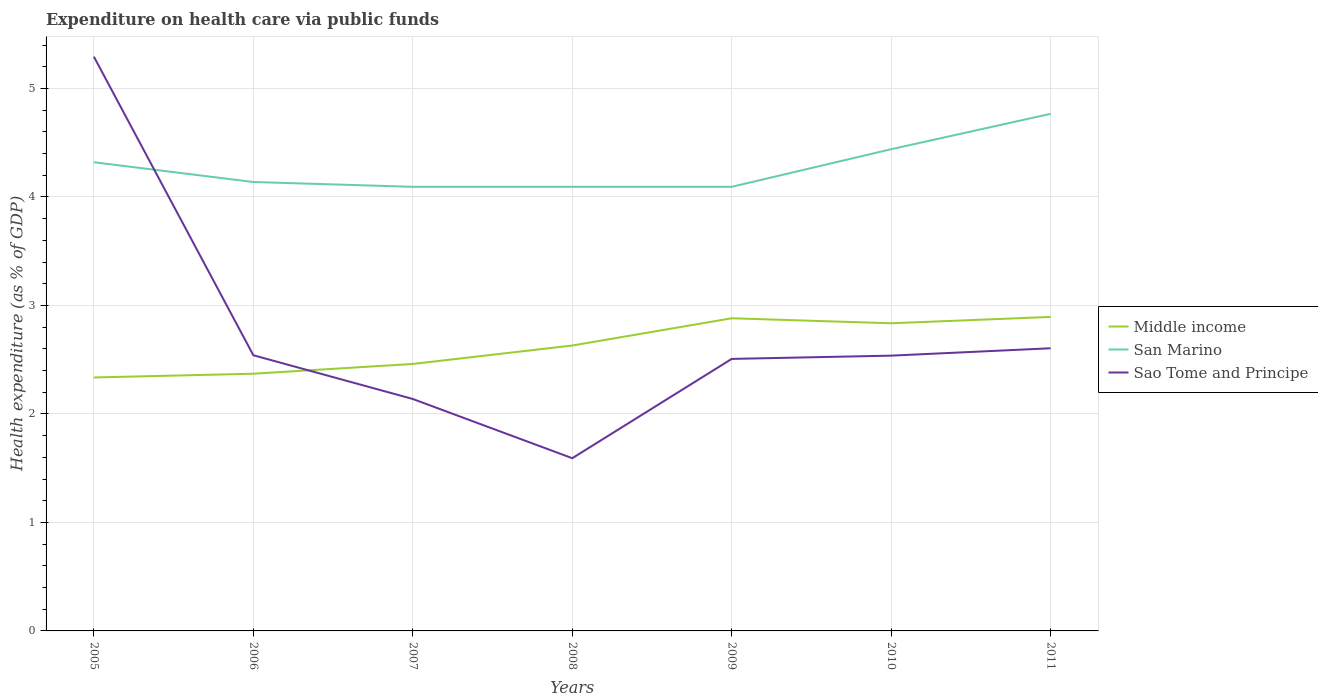Is the number of lines equal to the number of legend labels?
Keep it short and to the point. Yes. Across all years, what is the maximum expenditure made on health care in Middle income?
Ensure brevity in your answer.  2.34. In which year was the expenditure made on health care in San Marino maximum?
Offer a very short reply. 2009. What is the total expenditure made on health care in San Marino in the graph?
Offer a terse response. -0.67. What is the difference between the highest and the second highest expenditure made on health care in Middle income?
Your response must be concise. 0.56. What is the difference between the highest and the lowest expenditure made on health care in San Marino?
Provide a succinct answer. 3. Is the expenditure made on health care in Middle income strictly greater than the expenditure made on health care in San Marino over the years?
Give a very brief answer. Yes. How many lines are there?
Your response must be concise. 3. What is the difference between two consecutive major ticks on the Y-axis?
Offer a very short reply. 1. Does the graph contain any zero values?
Provide a short and direct response. No. Does the graph contain grids?
Keep it short and to the point. Yes. How many legend labels are there?
Ensure brevity in your answer.  3. What is the title of the graph?
Offer a very short reply. Expenditure on health care via public funds. What is the label or title of the Y-axis?
Provide a short and direct response. Health expenditure (as % of GDP). What is the Health expenditure (as % of GDP) in Middle income in 2005?
Ensure brevity in your answer.  2.34. What is the Health expenditure (as % of GDP) of San Marino in 2005?
Your answer should be compact. 4.32. What is the Health expenditure (as % of GDP) in Sao Tome and Principe in 2005?
Ensure brevity in your answer.  5.29. What is the Health expenditure (as % of GDP) in Middle income in 2006?
Offer a terse response. 2.37. What is the Health expenditure (as % of GDP) in San Marino in 2006?
Give a very brief answer. 4.14. What is the Health expenditure (as % of GDP) of Sao Tome and Principe in 2006?
Give a very brief answer. 2.54. What is the Health expenditure (as % of GDP) of Middle income in 2007?
Your response must be concise. 2.46. What is the Health expenditure (as % of GDP) in San Marino in 2007?
Keep it short and to the point. 4.09. What is the Health expenditure (as % of GDP) of Sao Tome and Principe in 2007?
Give a very brief answer. 2.14. What is the Health expenditure (as % of GDP) in Middle income in 2008?
Offer a very short reply. 2.63. What is the Health expenditure (as % of GDP) of San Marino in 2008?
Provide a short and direct response. 4.09. What is the Health expenditure (as % of GDP) of Sao Tome and Principe in 2008?
Your response must be concise. 1.59. What is the Health expenditure (as % of GDP) of Middle income in 2009?
Your answer should be very brief. 2.88. What is the Health expenditure (as % of GDP) of San Marino in 2009?
Your response must be concise. 4.09. What is the Health expenditure (as % of GDP) in Sao Tome and Principe in 2009?
Your answer should be compact. 2.51. What is the Health expenditure (as % of GDP) in Middle income in 2010?
Make the answer very short. 2.84. What is the Health expenditure (as % of GDP) of San Marino in 2010?
Give a very brief answer. 4.44. What is the Health expenditure (as % of GDP) in Sao Tome and Principe in 2010?
Your response must be concise. 2.54. What is the Health expenditure (as % of GDP) in Middle income in 2011?
Provide a succinct answer. 2.89. What is the Health expenditure (as % of GDP) in San Marino in 2011?
Provide a succinct answer. 4.77. What is the Health expenditure (as % of GDP) of Sao Tome and Principe in 2011?
Make the answer very short. 2.61. Across all years, what is the maximum Health expenditure (as % of GDP) in Middle income?
Your answer should be compact. 2.89. Across all years, what is the maximum Health expenditure (as % of GDP) in San Marino?
Ensure brevity in your answer.  4.77. Across all years, what is the maximum Health expenditure (as % of GDP) of Sao Tome and Principe?
Your answer should be very brief. 5.29. Across all years, what is the minimum Health expenditure (as % of GDP) of Middle income?
Provide a succinct answer. 2.34. Across all years, what is the minimum Health expenditure (as % of GDP) of San Marino?
Your answer should be very brief. 4.09. Across all years, what is the minimum Health expenditure (as % of GDP) in Sao Tome and Principe?
Your response must be concise. 1.59. What is the total Health expenditure (as % of GDP) of Middle income in the graph?
Offer a terse response. 18.41. What is the total Health expenditure (as % of GDP) in San Marino in the graph?
Offer a terse response. 29.95. What is the total Health expenditure (as % of GDP) in Sao Tome and Principe in the graph?
Your answer should be compact. 19.21. What is the difference between the Health expenditure (as % of GDP) in Middle income in 2005 and that in 2006?
Your response must be concise. -0.03. What is the difference between the Health expenditure (as % of GDP) in San Marino in 2005 and that in 2006?
Ensure brevity in your answer.  0.18. What is the difference between the Health expenditure (as % of GDP) in Sao Tome and Principe in 2005 and that in 2006?
Offer a terse response. 2.75. What is the difference between the Health expenditure (as % of GDP) in Middle income in 2005 and that in 2007?
Provide a short and direct response. -0.12. What is the difference between the Health expenditure (as % of GDP) in San Marino in 2005 and that in 2007?
Offer a very short reply. 0.23. What is the difference between the Health expenditure (as % of GDP) of Sao Tome and Principe in 2005 and that in 2007?
Make the answer very short. 3.16. What is the difference between the Health expenditure (as % of GDP) in Middle income in 2005 and that in 2008?
Provide a succinct answer. -0.29. What is the difference between the Health expenditure (as % of GDP) in San Marino in 2005 and that in 2008?
Make the answer very short. 0.23. What is the difference between the Health expenditure (as % of GDP) in Sao Tome and Principe in 2005 and that in 2008?
Your answer should be very brief. 3.7. What is the difference between the Health expenditure (as % of GDP) in Middle income in 2005 and that in 2009?
Your answer should be compact. -0.55. What is the difference between the Health expenditure (as % of GDP) of San Marino in 2005 and that in 2009?
Make the answer very short. 0.23. What is the difference between the Health expenditure (as % of GDP) in Sao Tome and Principe in 2005 and that in 2009?
Your answer should be very brief. 2.79. What is the difference between the Health expenditure (as % of GDP) of Middle income in 2005 and that in 2010?
Your answer should be compact. -0.5. What is the difference between the Health expenditure (as % of GDP) in San Marino in 2005 and that in 2010?
Keep it short and to the point. -0.12. What is the difference between the Health expenditure (as % of GDP) in Sao Tome and Principe in 2005 and that in 2010?
Provide a short and direct response. 2.76. What is the difference between the Health expenditure (as % of GDP) in Middle income in 2005 and that in 2011?
Provide a short and direct response. -0.56. What is the difference between the Health expenditure (as % of GDP) in San Marino in 2005 and that in 2011?
Keep it short and to the point. -0.45. What is the difference between the Health expenditure (as % of GDP) in Sao Tome and Principe in 2005 and that in 2011?
Keep it short and to the point. 2.69. What is the difference between the Health expenditure (as % of GDP) in Middle income in 2006 and that in 2007?
Ensure brevity in your answer.  -0.09. What is the difference between the Health expenditure (as % of GDP) in San Marino in 2006 and that in 2007?
Provide a short and direct response. 0.04. What is the difference between the Health expenditure (as % of GDP) in Sao Tome and Principe in 2006 and that in 2007?
Make the answer very short. 0.4. What is the difference between the Health expenditure (as % of GDP) of Middle income in 2006 and that in 2008?
Keep it short and to the point. -0.26. What is the difference between the Health expenditure (as % of GDP) of San Marino in 2006 and that in 2008?
Offer a very short reply. 0.04. What is the difference between the Health expenditure (as % of GDP) in Sao Tome and Principe in 2006 and that in 2008?
Ensure brevity in your answer.  0.95. What is the difference between the Health expenditure (as % of GDP) of Middle income in 2006 and that in 2009?
Make the answer very short. -0.51. What is the difference between the Health expenditure (as % of GDP) in San Marino in 2006 and that in 2009?
Your answer should be very brief. 0.04. What is the difference between the Health expenditure (as % of GDP) of Sao Tome and Principe in 2006 and that in 2009?
Your response must be concise. 0.03. What is the difference between the Health expenditure (as % of GDP) in Middle income in 2006 and that in 2010?
Keep it short and to the point. -0.47. What is the difference between the Health expenditure (as % of GDP) of San Marino in 2006 and that in 2010?
Give a very brief answer. -0.3. What is the difference between the Health expenditure (as % of GDP) in Sao Tome and Principe in 2006 and that in 2010?
Make the answer very short. 0. What is the difference between the Health expenditure (as % of GDP) in Middle income in 2006 and that in 2011?
Your response must be concise. -0.52. What is the difference between the Health expenditure (as % of GDP) of San Marino in 2006 and that in 2011?
Keep it short and to the point. -0.63. What is the difference between the Health expenditure (as % of GDP) in Sao Tome and Principe in 2006 and that in 2011?
Your answer should be compact. -0.06. What is the difference between the Health expenditure (as % of GDP) of Middle income in 2007 and that in 2008?
Provide a succinct answer. -0.17. What is the difference between the Health expenditure (as % of GDP) of San Marino in 2007 and that in 2008?
Ensure brevity in your answer.  -0. What is the difference between the Health expenditure (as % of GDP) in Sao Tome and Principe in 2007 and that in 2008?
Your response must be concise. 0.55. What is the difference between the Health expenditure (as % of GDP) in Middle income in 2007 and that in 2009?
Offer a terse response. -0.42. What is the difference between the Health expenditure (as % of GDP) of Sao Tome and Principe in 2007 and that in 2009?
Your response must be concise. -0.37. What is the difference between the Health expenditure (as % of GDP) in Middle income in 2007 and that in 2010?
Your answer should be very brief. -0.37. What is the difference between the Health expenditure (as % of GDP) in San Marino in 2007 and that in 2010?
Provide a short and direct response. -0.35. What is the difference between the Health expenditure (as % of GDP) of Sao Tome and Principe in 2007 and that in 2010?
Your answer should be very brief. -0.4. What is the difference between the Health expenditure (as % of GDP) in Middle income in 2007 and that in 2011?
Your response must be concise. -0.43. What is the difference between the Health expenditure (as % of GDP) in San Marino in 2007 and that in 2011?
Ensure brevity in your answer.  -0.67. What is the difference between the Health expenditure (as % of GDP) of Sao Tome and Principe in 2007 and that in 2011?
Offer a very short reply. -0.47. What is the difference between the Health expenditure (as % of GDP) in Middle income in 2008 and that in 2009?
Provide a short and direct response. -0.25. What is the difference between the Health expenditure (as % of GDP) in Sao Tome and Principe in 2008 and that in 2009?
Offer a very short reply. -0.92. What is the difference between the Health expenditure (as % of GDP) in Middle income in 2008 and that in 2010?
Keep it short and to the point. -0.2. What is the difference between the Health expenditure (as % of GDP) of San Marino in 2008 and that in 2010?
Offer a very short reply. -0.35. What is the difference between the Health expenditure (as % of GDP) of Sao Tome and Principe in 2008 and that in 2010?
Your response must be concise. -0.95. What is the difference between the Health expenditure (as % of GDP) in Middle income in 2008 and that in 2011?
Offer a terse response. -0.26. What is the difference between the Health expenditure (as % of GDP) in San Marino in 2008 and that in 2011?
Give a very brief answer. -0.67. What is the difference between the Health expenditure (as % of GDP) in Sao Tome and Principe in 2008 and that in 2011?
Offer a very short reply. -1.01. What is the difference between the Health expenditure (as % of GDP) of Middle income in 2009 and that in 2010?
Keep it short and to the point. 0.05. What is the difference between the Health expenditure (as % of GDP) in San Marino in 2009 and that in 2010?
Your answer should be very brief. -0.35. What is the difference between the Health expenditure (as % of GDP) in Sao Tome and Principe in 2009 and that in 2010?
Provide a short and direct response. -0.03. What is the difference between the Health expenditure (as % of GDP) in Middle income in 2009 and that in 2011?
Offer a very short reply. -0.01. What is the difference between the Health expenditure (as % of GDP) of San Marino in 2009 and that in 2011?
Ensure brevity in your answer.  -0.67. What is the difference between the Health expenditure (as % of GDP) of Sao Tome and Principe in 2009 and that in 2011?
Your response must be concise. -0.1. What is the difference between the Health expenditure (as % of GDP) of Middle income in 2010 and that in 2011?
Give a very brief answer. -0.06. What is the difference between the Health expenditure (as % of GDP) in San Marino in 2010 and that in 2011?
Offer a terse response. -0.33. What is the difference between the Health expenditure (as % of GDP) in Sao Tome and Principe in 2010 and that in 2011?
Your answer should be compact. -0.07. What is the difference between the Health expenditure (as % of GDP) in Middle income in 2005 and the Health expenditure (as % of GDP) in San Marino in 2006?
Ensure brevity in your answer.  -1.8. What is the difference between the Health expenditure (as % of GDP) in Middle income in 2005 and the Health expenditure (as % of GDP) in Sao Tome and Principe in 2006?
Your answer should be very brief. -0.2. What is the difference between the Health expenditure (as % of GDP) of San Marino in 2005 and the Health expenditure (as % of GDP) of Sao Tome and Principe in 2006?
Your answer should be compact. 1.78. What is the difference between the Health expenditure (as % of GDP) in Middle income in 2005 and the Health expenditure (as % of GDP) in San Marino in 2007?
Offer a very short reply. -1.76. What is the difference between the Health expenditure (as % of GDP) of Middle income in 2005 and the Health expenditure (as % of GDP) of Sao Tome and Principe in 2007?
Provide a short and direct response. 0.2. What is the difference between the Health expenditure (as % of GDP) of San Marino in 2005 and the Health expenditure (as % of GDP) of Sao Tome and Principe in 2007?
Ensure brevity in your answer.  2.18. What is the difference between the Health expenditure (as % of GDP) of Middle income in 2005 and the Health expenditure (as % of GDP) of San Marino in 2008?
Your response must be concise. -1.76. What is the difference between the Health expenditure (as % of GDP) in Middle income in 2005 and the Health expenditure (as % of GDP) in Sao Tome and Principe in 2008?
Offer a terse response. 0.74. What is the difference between the Health expenditure (as % of GDP) in San Marino in 2005 and the Health expenditure (as % of GDP) in Sao Tome and Principe in 2008?
Offer a terse response. 2.73. What is the difference between the Health expenditure (as % of GDP) of Middle income in 2005 and the Health expenditure (as % of GDP) of San Marino in 2009?
Offer a terse response. -1.76. What is the difference between the Health expenditure (as % of GDP) of Middle income in 2005 and the Health expenditure (as % of GDP) of Sao Tome and Principe in 2009?
Provide a succinct answer. -0.17. What is the difference between the Health expenditure (as % of GDP) of San Marino in 2005 and the Health expenditure (as % of GDP) of Sao Tome and Principe in 2009?
Your answer should be compact. 1.81. What is the difference between the Health expenditure (as % of GDP) of Middle income in 2005 and the Health expenditure (as % of GDP) of San Marino in 2010?
Make the answer very short. -2.1. What is the difference between the Health expenditure (as % of GDP) of Middle income in 2005 and the Health expenditure (as % of GDP) of Sao Tome and Principe in 2010?
Your answer should be very brief. -0.2. What is the difference between the Health expenditure (as % of GDP) in San Marino in 2005 and the Health expenditure (as % of GDP) in Sao Tome and Principe in 2010?
Your answer should be compact. 1.78. What is the difference between the Health expenditure (as % of GDP) in Middle income in 2005 and the Health expenditure (as % of GDP) in San Marino in 2011?
Give a very brief answer. -2.43. What is the difference between the Health expenditure (as % of GDP) in Middle income in 2005 and the Health expenditure (as % of GDP) in Sao Tome and Principe in 2011?
Offer a very short reply. -0.27. What is the difference between the Health expenditure (as % of GDP) of San Marino in 2005 and the Health expenditure (as % of GDP) of Sao Tome and Principe in 2011?
Your response must be concise. 1.71. What is the difference between the Health expenditure (as % of GDP) of Middle income in 2006 and the Health expenditure (as % of GDP) of San Marino in 2007?
Make the answer very short. -1.72. What is the difference between the Health expenditure (as % of GDP) in Middle income in 2006 and the Health expenditure (as % of GDP) in Sao Tome and Principe in 2007?
Your response must be concise. 0.23. What is the difference between the Health expenditure (as % of GDP) of Middle income in 2006 and the Health expenditure (as % of GDP) of San Marino in 2008?
Your response must be concise. -1.72. What is the difference between the Health expenditure (as % of GDP) in Middle income in 2006 and the Health expenditure (as % of GDP) in Sao Tome and Principe in 2008?
Ensure brevity in your answer.  0.78. What is the difference between the Health expenditure (as % of GDP) of San Marino in 2006 and the Health expenditure (as % of GDP) of Sao Tome and Principe in 2008?
Provide a succinct answer. 2.55. What is the difference between the Health expenditure (as % of GDP) of Middle income in 2006 and the Health expenditure (as % of GDP) of San Marino in 2009?
Keep it short and to the point. -1.72. What is the difference between the Health expenditure (as % of GDP) in Middle income in 2006 and the Health expenditure (as % of GDP) in Sao Tome and Principe in 2009?
Provide a short and direct response. -0.14. What is the difference between the Health expenditure (as % of GDP) in San Marino in 2006 and the Health expenditure (as % of GDP) in Sao Tome and Principe in 2009?
Give a very brief answer. 1.63. What is the difference between the Health expenditure (as % of GDP) of Middle income in 2006 and the Health expenditure (as % of GDP) of San Marino in 2010?
Your answer should be very brief. -2.07. What is the difference between the Health expenditure (as % of GDP) of Middle income in 2006 and the Health expenditure (as % of GDP) of Sao Tome and Principe in 2010?
Your answer should be compact. -0.17. What is the difference between the Health expenditure (as % of GDP) in San Marino in 2006 and the Health expenditure (as % of GDP) in Sao Tome and Principe in 2010?
Make the answer very short. 1.6. What is the difference between the Health expenditure (as % of GDP) in Middle income in 2006 and the Health expenditure (as % of GDP) in San Marino in 2011?
Give a very brief answer. -2.4. What is the difference between the Health expenditure (as % of GDP) of Middle income in 2006 and the Health expenditure (as % of GDP) of Sao Tome and Principe in 2011?
Give a very brief answer. -0.23. What is the difference between the Health expenditure (as % of GDP) of San Marino in 2006 and the Health expenditure (as % of GDP) of Sao Tome and Principe in 2011?
Your answer should be compact. 1.53. What is the difference between the Health expenditure (as % of GDP) in Middle income in 2007 and the Health expenditure (as % of GDP) in San Marino in 2008?
Provide a succinct answer. -1.63. What is the difference between the Health expenditure (as % of GDP) in Middle income in 2007 and the Health expenditure (as % of GDP) in Sao Tome and Principe in 2008?
Your answer should be very brief. 0.87. What is the difference between the Health expenditure (as % of GDP) of San Marino in 2007 and the Health expenditure (as % of GDP) of Sao Tome and Principe in 2008?
Your response must be concise. 2.5. What is the difference between the Health expenditure (as % of GDP) in Middle income in 2007 and the Health expenditure (as % of GDP) in San Marino in 2009?
Provide a succinct answer. -1.63. What is the difference between the Health expenditure (as % of GDP) of Middle income in 2007 and the Health expenditure (as % of GDP) of Sao Tome and Principe in 2009?
Give a very brief answer. -0.05. What is the difference between the Health expenditure (as % of GDP) in San Marino in 2007 and the Health expenditure (as % of GDP) in Sao Tome and Principe in 2009?
Ensure brevity in your answer.  1.59. What is the difference between the Health expenditure (as % of GDP) of Middle income in 2007 and the Health expenditure (as % of GDP) of San Marino in 2010?
Keep it short and to the point. -1.98. What is the difference between the Health expenditure (as % of GDP) of Middle income in 2007 and the Health expenditure (as % of GDP) of Sao Tome and Principe in 2010?
Offer a terse response. -0.08. What is the difference between the Health expenditure (as % of GDP) of San Marino in 2007 and the Health expenditure (as % of GDP) of Sao Tome and Principe in 2010?
Your answer should be compact. 1.56. What is the difference between the Health expenditure (as % of GDP) of Middle income in 2007 and the Health expenditure (as % of GDP) of San Marino in 2011?
Provide a succinct answer. -2.31. What is the difference between the Health expenditure (as % of GDP) of Middle income in 2007 and the Health expenditure (as % of GDP) of Sao Tome and Principe in 2011?
Your response must be concise. -0.14. What is the difference between the Health expenditure (as % of GDP) in San Marino in 2007 and the Health expenditure (as % of GDP) in Sao Tome and Principe in 2011?
Make the answer very short. 1.49. What is the difference between the Health expenditure (as % of GDP) in Middle income in 2008 and the Health expenditure (as % of GDP) in San Marino in 2009?
Ensure brevity in your answer.  -1.46. What is the difference between the Health expenditure (as % of GDP) of Middle income in 2008 and the Health expenditure (as % of GDP) of Sao Tome and Principe in 2009?
Offer a terse response. 0.12. What is the difference between the Health expenditure (as % of GDP) in San Marino in 2008 and the Health expenditure (as % of GDP) in Sao Tome and Principe in 2009?
Your response must be concise. 1.59. What is the difference between the Health expenditure (as % of GDP) in Middle income in 2008 and the Health expenditure (as % of GDP) in San Marino in 2010?
Keep it short and to the point. -1.81. What is the difference between the Health expenditure (as % of GDP) in Middle income in 2008 and the Health expenditure (as % of GDP) in Sao Tome and Principe in 2010?
Offer a terse response. 0.09. What is the difference between the Health expenditure (as % of GDP) in San Marino in 2008 and the Health expenditure (as % of GDP) in Sao Tome and Principe in 2010?
Keep it short and to the point. 1.56. What is the difference between the Health expenditure (as % of GDP) of Middle income in 2008 and the Health expenditure (as % of GDP) of San Marino in 2011?
Your response must be concise. -2.14. What is the difference between the Health expenditure (as % of GDP) of Middle income in 2008 and the Health expenditure (as % of GDP) of Sao Tome and Principe in 2011?
Keep it short and to the point. 0.03. What is the difference between the Health expenditure (as % of GDP) in San Marino in 2008 and the Health expenditure (as % of GDP) in Sao Tome and Principe in 2011?
Offer a terse response. 1.49. What is the difference between the Health expenditure (as % of GDP) of Middle income in 2009 and the Health expenditure (as % of GDP) of San Marino in 2010?
Your response must be concise. -1.56. What is the difference between the Health expenditure (as % of GDP) of Middle income in 2009 and the Health expenditure (as % of GDP) of Sao Tome and Principe in 2010?
Your response must be concise. 0.34. What is the difference between the Health expenditure (as % of GDP) in San Marino in 2009 and the Health expenditure (as % of GDP) in Sao Tome and Principe in 2010?
Make the answer very short. 1.56. What is the difference between the Health expenditure (as % of GDP) in Middle income in 2009 and the Health expenditure (as % of GDP) in San Marino in 2011?
Provide a short and direct response. -1.88. What is the difference between the Health expenditure (as % of GDP) of Middle income in 2009 and the Health expenditure (as % of GDP) of Sao Tome and Principe in 2011?
Ensure brevity in your answer.  0.28. What is the difference between the Health expenditure (as % of GDP) of San Marino in 2009 and the Health expenditure (as % of GDP) of Sao Tome and Principe in 2011?
Your answer should be compact. 1.49. What is the difference between the Health expenditure (as % of GDP) in Middle income in 2010 and the Health expenditure (as % of GDP) in San Marino in 2011?
Provide a short and direct response. -1.93. What is the difference between the Health expenditure (as % of GDP) in Middle income in 2010 and the Health expenditure (as % of GDP) in Sao Tome and Principe in 2011?
Your response must be concise. 0.23. What is the difference between the Health expenditure (as % of GDP) of San Marino in 2010 and the Health expenditure (as % of GDP) of Sao Tome and Principe in 2011?
Keep it short and to the point. 1.83. What is the average Health expenditure (as % of GDP) in Middle income per year?
Make the answer very short. 2.63. What is the average Health expenditure (as % of GDP) in San Marino per year?
Provide a short and direct response. 4.28. What is the average Health expenditure (as % of GDP) in Sao Tome and Principe per year?
Your response must be concise. 2.74. In the year 2005, what is the difference between the Health expenditure (as % of GDP) of Middle income and Health expenditure (as % of GDP) of San Marino?
Offer a terse response. -1.98. In the year 2005, what is the difference between the Health expenditure (as % of GDP) in Middle income and Health expenditure (as % of GDP) in Sao Tome and Principe?
Your answer should be compact. -2.96. In the year 2005, what is the difference between the Health expenditure (as % of GDP) in San Marino and Health expenditure (as % of GDP) in Sao Tome and Principe?
Ensure brevity in your answer.  -0.97. In the year 2006, what is the difference between the Health expenditure (as % of GDP) in Middle income and Health expenditure (as % of GDP) in San Marino?
Keep it short and to the point. -1.77. In the year 2006, what is the difference between the Health expenditure (as % of GDP) in Middle income and Health expenditure (as % of GDP) in Sao Tome and Principe?
Your response must be concise. -0.17. In the year 2006, what is the difference between the Health expenditure (as % of GDP) in San Marino and Health expenditure (as % of GDP) in Sao Tome and Principe?
Your answer should be compact. 1.6. In the year 2007, what is the difference between the Health expenditure (as % of GDP) in Middle income and Health expenditure (as % of GDP) in San Marino?
Provide a succinct answer. -1.63. In the year 2007, what is the difference between the Health expenditure (as % of GDP) of Middle income and Health expenditure (as % of GDP) of Sao Tome and Principe?
Offer a terse response. 0.32. In the year 2007, what is the difference between the Health expenditure (as % of GDP) of San Marino and Health expenditure (as % of GDP) of Sao Tome and Principe?
Make the answer very short. 1.96. In the year 2008, what is the difference between the Health expenditure (as % of GDP) in Middle income and Health expenditure (as % of GDP) in San Marino?
Your answer should be very brief. -1.46. In the year 2008, what is the difference between the Health expenditure (as % of GDP) of Middle income and Health expenditure (as % of GDP) of Sao Tome and Principe?
Your answer should be compact. 1.04. In the year 2008, what is the difference between the Health expenditure (as % of GDP) in San Marino and Health expenditure (as % of GDP) in Sao Tome and Principe?
Keep it short and to the point. 2.5. In the year 2009, what is the difference between the Health expenditure (as % of GDP) in Middle income and Health expenditure (as % of GDP) in San Marino?
Offer a terse response. -1.21. In the year 2009, what is the difference between the Health expenditure (as % of GDP) of Middle income and Health expenditure (as % of GDP) of Sao Tome and Principe?
Your answer should be compact. 0.37. In the year 2009, what is the difference between the Health expenditure (as % of GDP) in San Marino and Health expenditure (as % of GDP) in Sao Tome and Principe?
Provide a short and direct response. 1.59. In the year 2010, what is the difference between the Health expenditure (as % of GDP) in Middle income and Health expenditure (as % of GDP) in San Marino?
Your answer should be compact. -1.6. In the year 2010, what is the difference between the Health expenditure (as % of GDP) in Middle income and Health expenditure (as % of GDP) in Sao Tome and Principe?
Give a very brief answer. 0.3. In the year 2010, what is the difference between the Health expenditure (as % of GDP) of San Marino and Health expenditure (as % of GDP) of Sao Tome and Principe?
Ensure brevity in your answer.  1.9. In the year 2011, what is the difference between the Health expenditure (as % of GDP) of Middle income and Health expenditure (as % of GDP) of San Marino?
Keep it short and to the point. -1.87. In the year 2011, what is the difference between the Health expenditure (as % of GDP) of Middle income and Health expenditure (as % of GDP) of Sao Tome and Principe?
Offer a very short reply. 0.29. In the year 2011, what is the difference between the Health expenditure (as % of GDP) in San Marino and Health expenditure (as % of GDP) in Sao Tome and Principe?
Your answer should be very brief. 2.16. What is the ratio of the Health expenditure (as % of GDP) of Middle income in 2005 to that in 2006?
Your answer should be compact. 0.99. What is the ratio of the Health expenditure (as % of GDP) in San Marino in 2005 to that in 2006?
Give a very brief answer. 1.04. What is the ratio of the Health expenditure (as % of GDP) of Sao Tome and Principe in 2005 to that in 2006?
Keep it short and to the point. 2.08. What is the ratio of the Health expenditure (as % of GDP) in Middle income in 2005 to that in 2007?
Your answer should be very brief. 0.95. What is the ratio of the Health expenditure (as % of GDP) in San Marino in 2005 to that in 2007?
Provide a succinct answer. 1.06. What is the ratio of the Health expenditure (as % of GDP) of Sao Tome and Principe in 2005 to that in 2007?
Provide a succinct answer. 2.48. What is the ratio of the Health expenditure (as % of GDP) in Middle income in 2005 to that in 2008?
Give a very brief answer. 0.89. What is the ratio of the Health expenditure (as % of GDP) of San Marino in 2005 to that in 2008?
Provide a succinct answer. 1.06. What is the ratio of the Health expenditure (as % of GDP) of Sao Tome and Principe in 2005 to that in 2008?
Your answer should be very brief. 3.32. What is the ratio of the Health expenditure (as % of GDP) in Middle income in 2005 to that in 2009?
Offer a terse response. 0.81. What is the ratio of the Health expenditure (as % of GDP) of San Marino in 2005 to that in 2009?
Give a very brief answer. 1.06. What is the ratio of the Health expenditure (as % of GDP) in Sao Tome and Principe in 2005 to that in 2009?
Your answer should be compact. 2.11. What is the ratio of the Health expenditure (as % of GDP) in Middle income in 2005 to that in 2010?
Give a very brief answer. 0.82. What is the ratio of the Health expenditure (as % of GDP) of Sao Tome and Principe in 2005 to that in 2010?
Give a very brief answer. 2.09. What is the ratio of the Health expenditure (as % of GDP) of Middle income in 2005 to that in 2011?
Ensure brevity in your answer.  0.81. What is the ratio of the Health expenditure (as % of GDP) in San Marino in 2005 to that in 2011?
Your answer should be very brief. 0.91. What is the ratio of the Health expenditure (as % of GDP) of Sao Tome and Principe in 2005 to that in 2011?
Offer a terse response. 2.03. What is the ratio of the Health expenditure (as % of GDP) in Middle income in 2006 to that in 2007?
Your answer should be very brief. 0.96. What is the ratio of the Health expenditure (as % of GDP) of San Marino in 2006 to that in 2007?
Make the answer very short. 1.01. What is the ratio of the Health expenditure (as % of GDP) of Sao Tome and Principe in 2006 to that in 2007?
Offer a very short reply. 1.19. What is the ratio of the Health expenditure (as % of GDP) of Middle income in 2006 to that in 2008?
Offer a very short reply. 0.9. What is the ratio of the Health expenditure (as % of GDP) of San Marino in 2006 to that in 2008?
Your response must be concise. 1.01. What is the ratio of the Health expenditure (as % of GDP) in Sao Tome and Principe in 2006 to that in 2008?
Your answer should be compact. 1.6. What is the ratio of the Health expenditure (as % of GDP) in Middle income in 2006 to that in 2009?
Ensure brevity in your answer.  0.82. What is the ratio of the Health expenditure (as % of GDP) in San Marino in 2006 to that in 2009?
Keep it short and to the point. 1.01. What is the ratio of the Health expenditure (as % of GDP) of Sao Tome and Principe in 2006 to that in 2009?
Offer a very short reply. 1.01. What is the ratio of the Health expenditure (as % of GDP) in Middle income in 2006 to that in 2010?
Offer a very short reply. 0.84. What is the ratio of the Health expenditure (as % of GDP) of San Marino in 2006 to that in 2010?
Keep it short and to the point. 0.93. What is the ratio of the Health expenditure (as % of GDP) of Middle income in 2006 to that in 2011?
Your answer should be compact. 0.82. What is the ratio of the Health expenditure (as % of GDP) in San Marino in 2006 to that in 2011?
Provide a short and direct response. 0.87. What is the ratio of the Health expenditure (as % of GDP) in Sao Tome and Principe in 2006 to that in 2011?
Give a very brief answer. 0.98. What is the ratio of the Health expenditure (as % of GDP) of Middle income in 2007 to that in 2008?
Your answer should be compact. 0.94. What is the ratio of the Health expenditure (as % of GDP) of Sao Tome and Principe in 2007 to that in 2008?
Provide a succinct answer. 1.34. What is the ratio of the Health expenditure (as % of GDP) of Middle income in 2007 to that in 2009?
Your answer should be compact. 0.85. What is the ratio of the Health expenditure (as % of GDP) in Sao Tome and Principe in 2007 to that in 2009?
Offer a terse response. 0.85. What is the ratio of the Health expenditure (as % of GDP) in Middle income in 2007 to that in 2010?
Your answer should be very brief. 0.87. What is the ratio of the Health expenditure (as % of GDP) of San Marino in 2007 to that in 2010?
Your response must be concise. 0.92. What is the ratio of the Health expenditure (as % of GDP) of Sao Tome and Principe in 2007 to that in 2010?
Provide a succinct answer. 0.84. What is the ratio of the Health expenditure (as % of GDP) in Middle income in 2007 to that in 2011?
Your answer should be compact. 0.85. What is the ratio of the Health expenditure (as % of GDP) in San Marino in 2007 to that in 2011?
Your answer should be compact. 0.86. What is the ratio of the Health expenditure (as % of GDP) in Sao Tome and Principe in 2007 to that in 2011?
Offer a terse response. 0.82. What is the ratio of the Health expenditure (as % of GDP) of Middle income in 2008 to that in 2009?
Offer a very short reply. 0.91. What is the ratio of the Health expenditure (as % of GDP) in San Marino in 2008 to that in 2009?
Offer a terse response. 1. What is the ratio of the Health expenditure (as % of GDP) in Sao Tome and Principe in 2008 to that in 2009?
Your answer should be very brief. 0.64. What is the ratio of the Health expenditure (as % of GDP) of Middle income in 2008 to that in 2010?
Make the answer very short. 0.93. What is the ratio of the Health expenditure (as % of GDP) in San Marino in 2008 to that in 2010?
Make the answer very short. 0.92. What is the ratio of the Health expenditure (as % of GDP) in Sao Tome and Principe in 2008 to that in 2010?
Offer a very short reply. 0.63. What is the ratio of the Health expenditure (as % of GDP) of Middle income in 2008 to that in 2011?
Ensure brevity in your answer.  0.91. What is the ratio of the Health expenditure (as % of GDP) of San Marino in 2008 to that in 2011?
Give a very brief answer. 0.86. What is the ratio of the Health expenditure (as % of GDP) in Sao Tome and Principe in 2008 to that in 2011?
Provide a succinct answer. 0.61. What is the ratio of the Health expenditure (as % of GDP) of Middle income in 2009 to that in 2010?
Provide a succinct answer. 1.02. What is the ratio of the Health expenditure (as % of GDP) in San Marino in 2009 to that in 2010?
Provide a succinct answer. 0.92. What is the ratio of the Health expenditure (as % of GDP) of Middle income in 2009 to that in 2011?
Your response must be concise. 1. What is the ratio of the Health expenditure (as % of GDP) in San Marino in 2009 to that in 2011?
Give a very brief answer. 0.86. What is the ratio of the Health expenditure (as % of GDP) of Sao Tome and Principe in 2009 to that in 2011?
Your response must be concise. 0.96. What is the ratio of the Health expenditure (as % of GDP) of Middle income in 2010 to that in 2011?
Provide a short and direct response. 0.98. What is the ratio of the Health expenditure (as % of GDP) of San Marino in 2010 to that in 2011?
Give a very brief answer. 0.93. What is the ratio of the Health expenditure (as % of GDP) of Sao Tome and Principe in 2010 to that in 2011?
Give a very brief answer. 0.97. What is the difference between the highest and the second highest Health expenditure (as % of GDP) in Middle income?
Your answer should be compact. 0.01. What is the difference between the highest and the second highest Health expenditure (as % of GDP) of San Marino?
Offer a very short reply. 0.33. What is the difference between the highest and the second highest Health expenditure (as % of GDP) in Sao Tome and Principe?
Give a very brief answer. 2.69. What is the difference between the highest and the lowest Health expenditure (as % of GDP) in Middle income?
Provide a short and direct response. 0.56. What is the difference between the highest and the lowest Health expenditure (as % of GDP) of San Marino?
Offer a terse response. 0.67. What is the difference between the highest and the lowest Health expenditure (as % of GDP) in Sao Tome and Principe?
Make the answer very short. 3.7. 